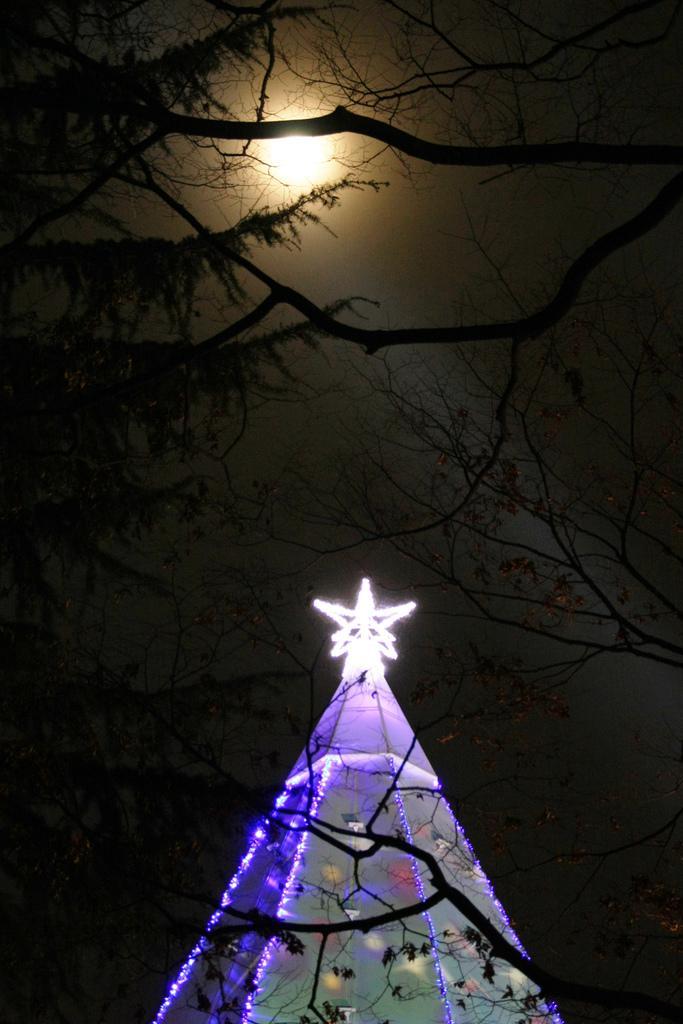Can you describe this image briefly? This picture shows a hit with lighting and we see trees and moon in the sky. 